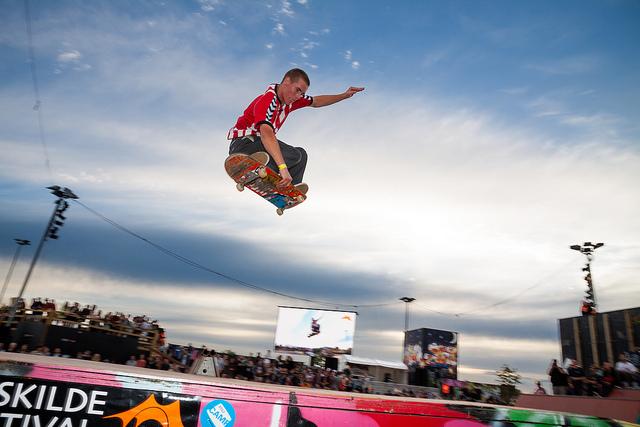What is the man riding?
Write a very short answer. Skateboard. Is this man wearing any protective gear?
Concise answer only. No. How many lights are on top of each pole?
Keep it brief. 4. 